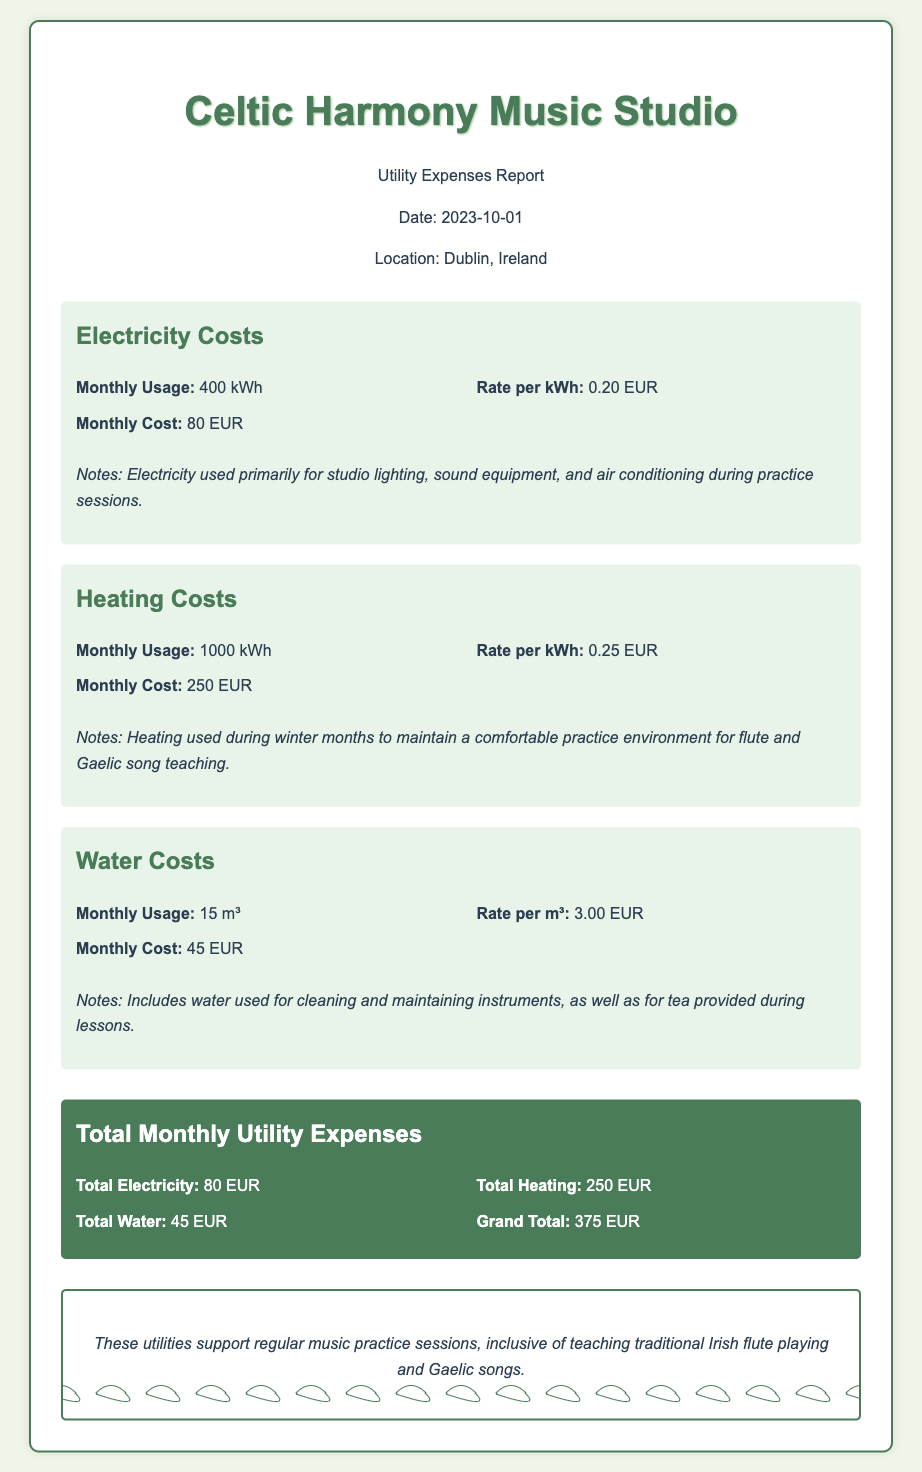What is the monthly electricity usage? The monthly electricity usage listed in the document is 400 kWh.
Answer: 400 kWh What is the rate per kWh for heating? The rate per kWh for heating is stated as 0.25 EUR.
Answer: 0.25 EUR How much is the total monthly cost for water? The total monthly cost for water is given as 45 EUR.
Answer: 45 EUR What is the grand total of all utility expenses? The grand total of all utility expenses combines electricity, heating, and water costs, totaling 375 EUR.
Answer: 375 EUR What notes are provided about electricity usage? The notes indicate that electricity is used primarily for studio lighting, sound equipment, and air conditioning during practice sessions.
Answer: Electricity used primarily for studio lighting, sound equipment, and air conditioning What month’s utility expenses are reported in the document? The utility expenses reported date is October 2023, specifically mentioned as 2023-10-01.
Answer: October 2023 What is the monthly usage of heating in kWh? The monthly usage of heating is recorded as 1000 kWh.
Answer: 1000 kWh Why is heating used during winter months? Heating is used during winter months to maintain a comfortable practice environment for flute and Gaelic song teaching.
Answer: To maintain a comfortable practice environment What style of font is used in the report? The document specifies the use of Gaelic and Irish Uncial font styles.
Answer: Gaelic, Irish Uncial 